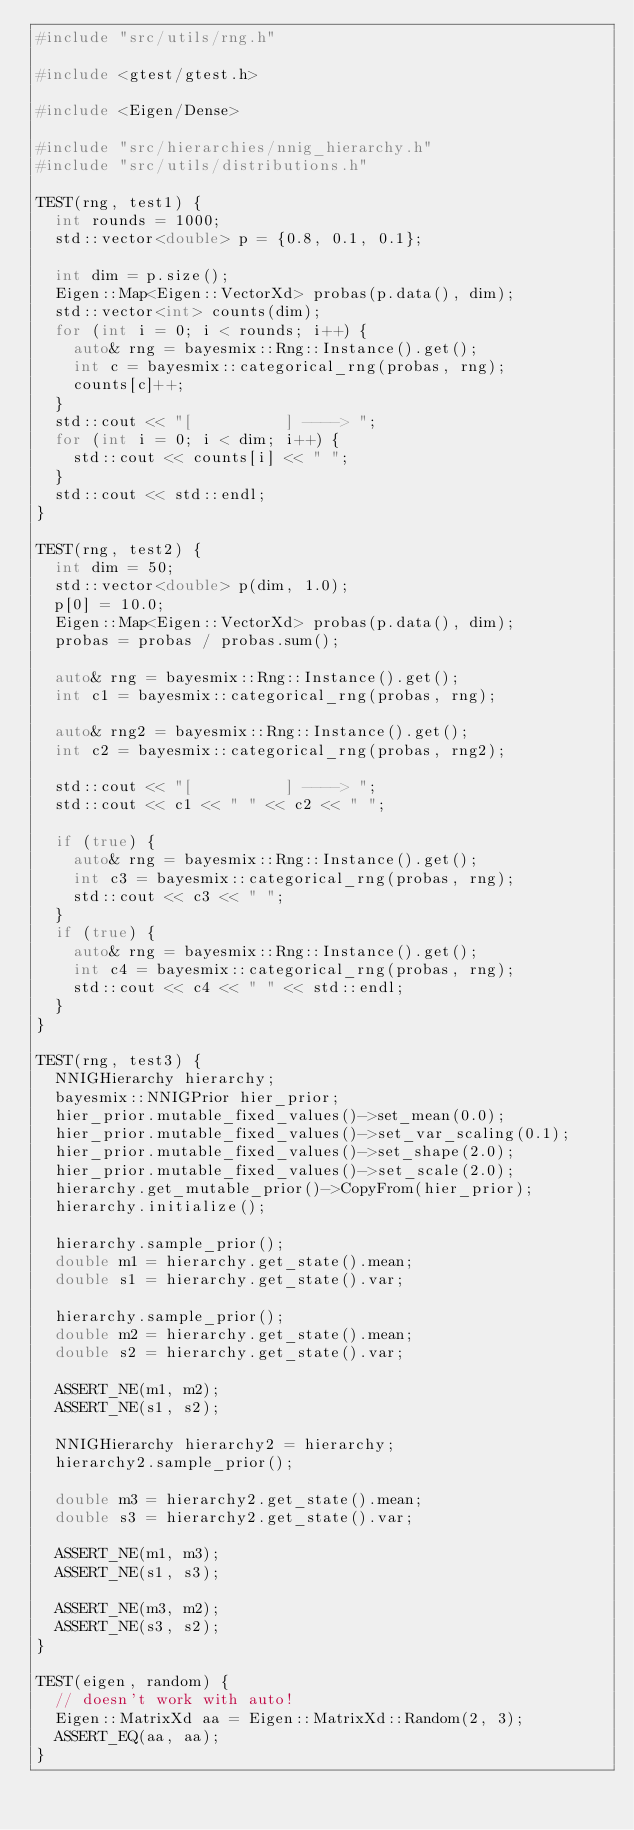Convert code to text. <code><loc_0><loc_0><loc_500><loc_500><_C++_>#include "src/utils/rng.h"

#include <gtest/gtest.h>

#include <Eigen/Dense>

#include "src/hierarchies/nnig_hierarchy.h"
#include "src/utils/distributions.h"

TEST(rng, test1) {
  int rounds = 1000;
  std::vector<double> p = {0.8, 0.1, 0.1};

  int dim = p.size();
  Eigen::Map<Eigen::VectorXd> probas(p.data(), dim);
  std::vector<int> counts(dim);
  for (int i = 0; i < rounds; i++) {
    auto& rng = bayesmix::Rng::Instance().get();
    int c = bayesmix::categorical_rng(probas, rng);
    counts[c]++;
  }
  std::cout << "[          ] ----> ";
  for (int i = 0; i < dim; i++) {
    std::cout << counts[i] << " ";
  }
  std::cout << std::endl;
}

TEST(rng, test2) {
  int dim = 50;
  std::vector<double> p(dim, 1.0);
  p[0] = 10.0;
  Eigen::Map<Eigen::VectorXd> probas(p.data(), dim);
  probas = probas / probas.sum();

  auto& rng = bayesmix::Rng::Instance().get();
  int c1 = bayesmix::categorical_rng(probas, rng);

  auto& rng2 = bayesmix::Rng::Instance().get();
  int c2 = bayesmix::categorical_rng(probas, rng2);

  std::cout << "[          ] ----> ";
  std::cout << c1 << " " << c2 << " ";

  if (true) {
    auto& rng = bayesmix::Rng::Instance().get();
    int c3 = bayesmix::categorical_rng(probas, rng);
    std::cout << c3 << " ";
  }
  if (true) {
    auto& rng = bayesmix::Rng::Instance().get();
    int c4 = bayesmix::categorical_rng(probas, rng);
    std::cout << c4 << " " << std::endl;
  }
}

TEST(rng, test3) {
  NNIGHierarchy hierarchy;
  bayesmix::NNIGPrior hier_prior;
  hier_prior.mutable_fixed_values()->set_mean(0.0);
  hier_prior.mutable_fixed_values()->set_var_scaling(0.1);
  hier_prior.mutable_fixed_values()->set_shape(2.0);
  hier_prior.mutable_fixed_values()->set_scale(2.0);
  hierarchy.get_mutable_prior()->CopyFrom(hier_prior);
  hierarchy.initialize();

  hierarchy.sample_prior();
  double m1 = hierarchy.get_state().mean;
  double s1 = hierarchy.get_state().var;

  hierarchy.sample_prior();
  double m2 = hierarchy.get_state().mean;
  double s2 = hierarchy.get_state().var;

  ASSERT_NE(m1, m2);
  ASSERT_NE(s1, s2);

  NNIGHierarchy hierarchy2 = hierarchy;
  hierarchy2.sample_prior();

  double m3 = hierarchy2.get_state().mean;
  double s3 = hierarchy2.get_state().var;

  ASSERT_NE(m1, m3);
  ASSERT_NE(s1, s3);

  ASSERT_NE(m3, m2);
  ASSERT_NE(s3, s2);
}

TEST(eigen, random) {
  // doesn't work with auto!
  Eigen::MatrixXd aa = Eigen::MatrixXd::Random(2, 3);
  ASSERT_EQ(aa, aa);
}
</code> 